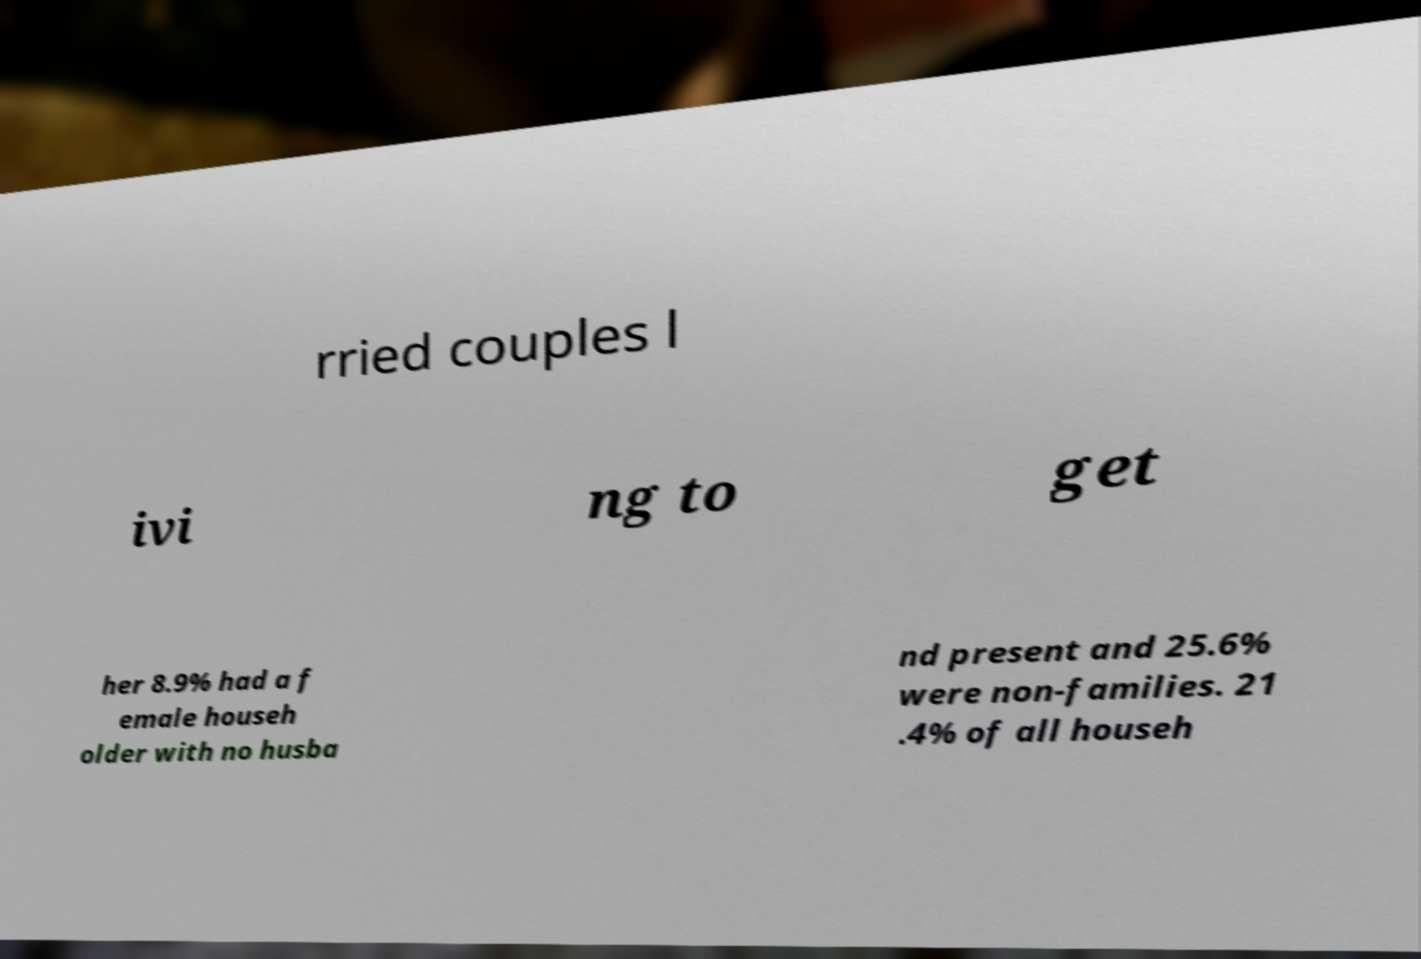What messages or text are displayed in this image? I need them in a readable, typed format. rried couples l ivi ng to get her 8.9% had a f emale househ older with no husba nd present and 25.6% were non-families. 21 .4% of all househ 